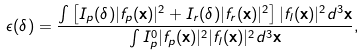<formula> <loc_0><loc_0><loc_500><loc_500>\epsilon ( \delta ) = \frac { \int \left [ I _ { p } ( \delta ) | f _ { p } ( \mathbf x ) | ^ { 2 } + I _ { r } ( \delta ) | f _ { r } ( \mathbf x ) | ^ { 2 } \right ] | f _ { l } ( \mathbf x ) | ^ { 2 } d ^ { 3 } \mathbf x } { \int I _ { p } ^ { 0 } | f _ { p } ( \mathbf x ) | ^ { 2 } | f _ { l } ( \mathbf x ) | ^ { 2 } d ^ { 3 } \mathbf x } ,</formula> 